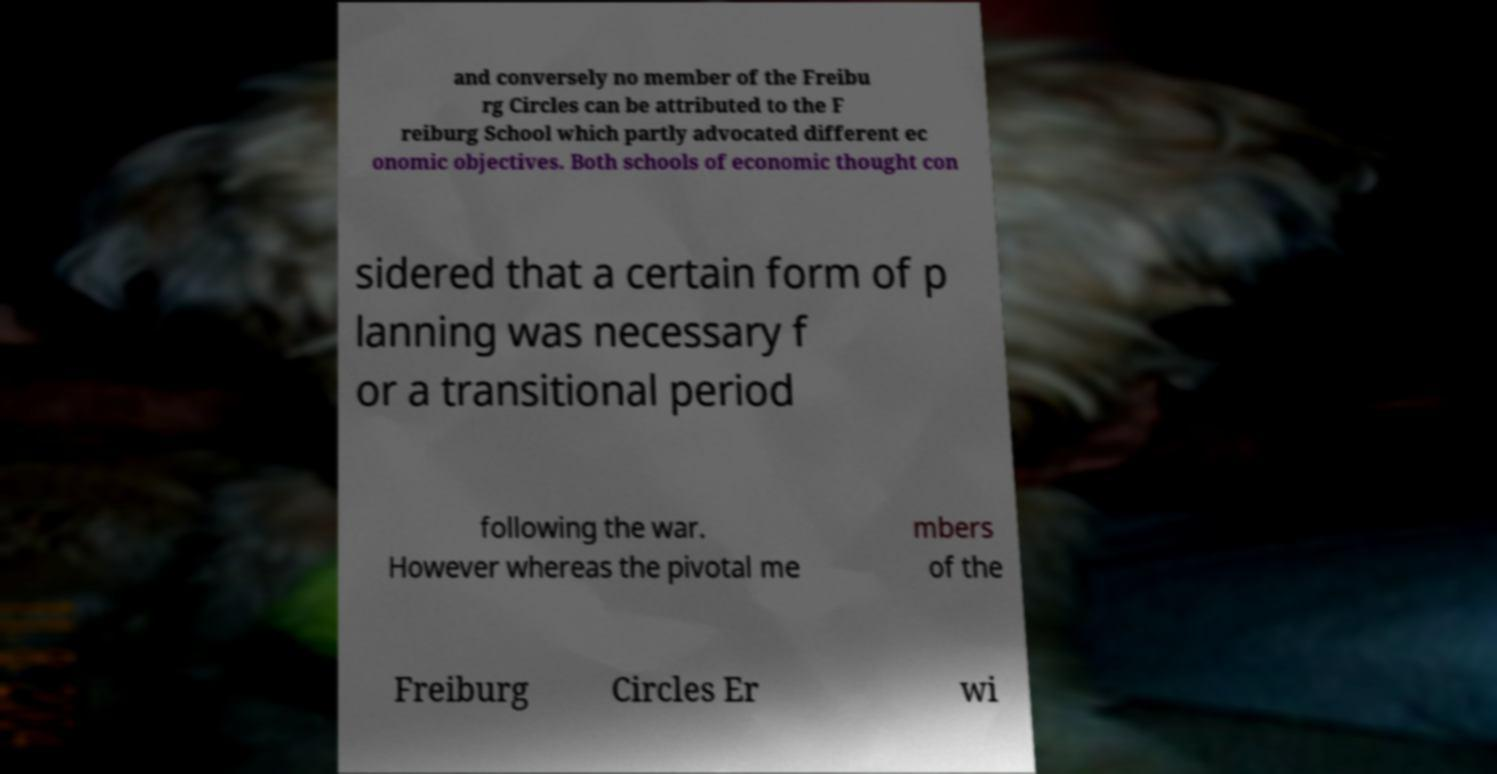Please identify and transcribe the text found in this image. and conversely no member of the Freibu rg Circles can be attributed to the F reiburg School which partly advocated different ec onomic objectives. Both schools of economic thought con sidered that a certain form of p lanning was necessary f or a transitional period following the war. However whereas the pivotal me mbers of the Freiburg Circles Er wi 